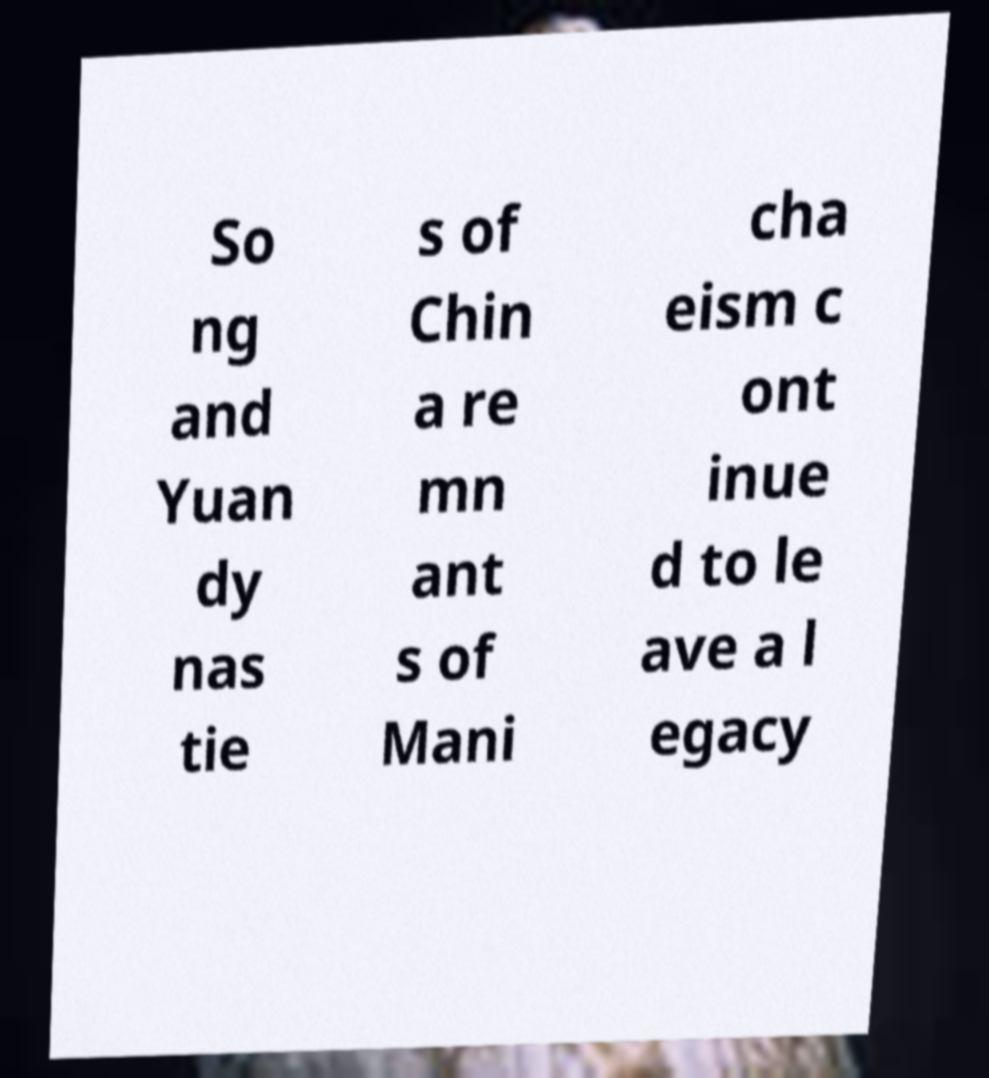Could you assist in decoding the text presented in this image and type it out clearly? So ng and Yuan dy nas tie s of Chin a re mn ant s of Mani cha eism c ont inue d to le ave a l egacy 